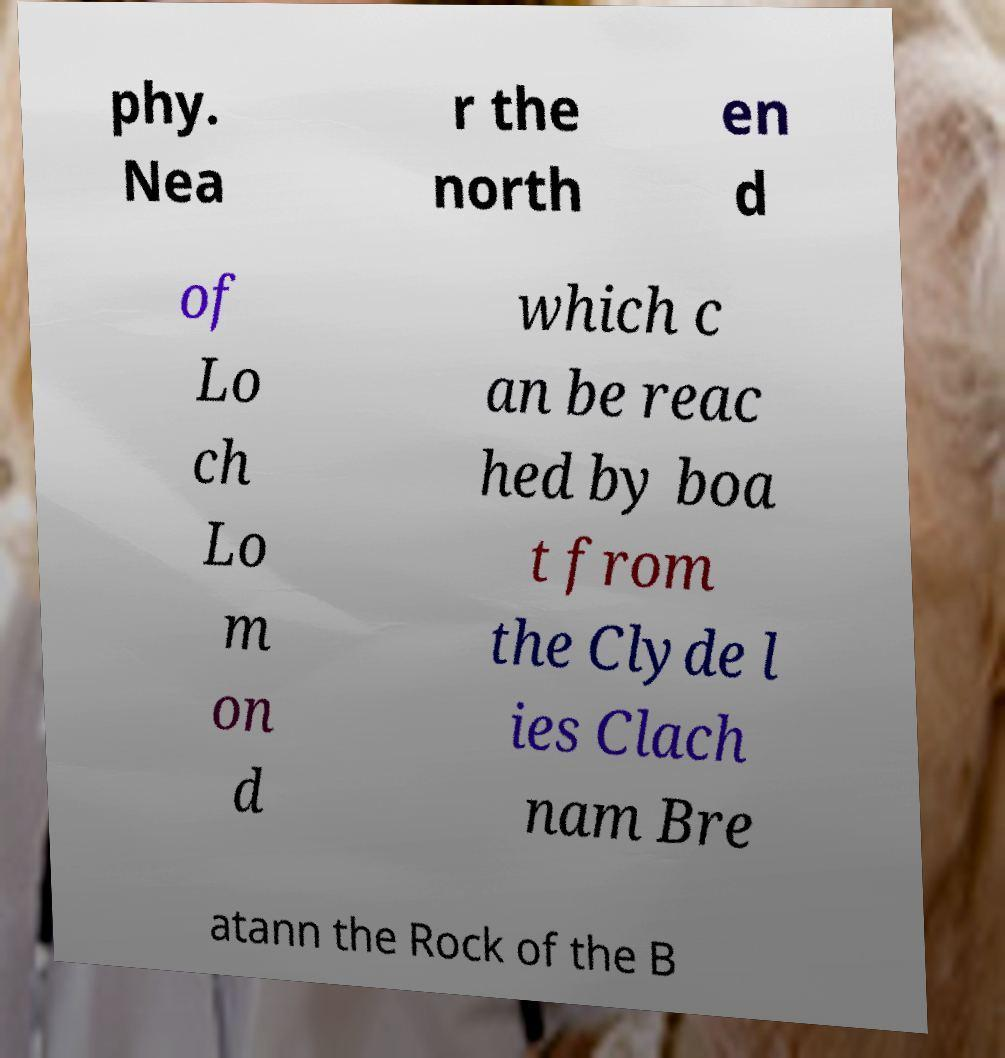There's text embedded in this image that I need extracted. Can you transcribe it verbatim? phy. Nea r the north en d of Lo ch Lo m on d which c an be reac hed by boa t from the Clyde l ies Clach nam Bre atann the Rock of the B 